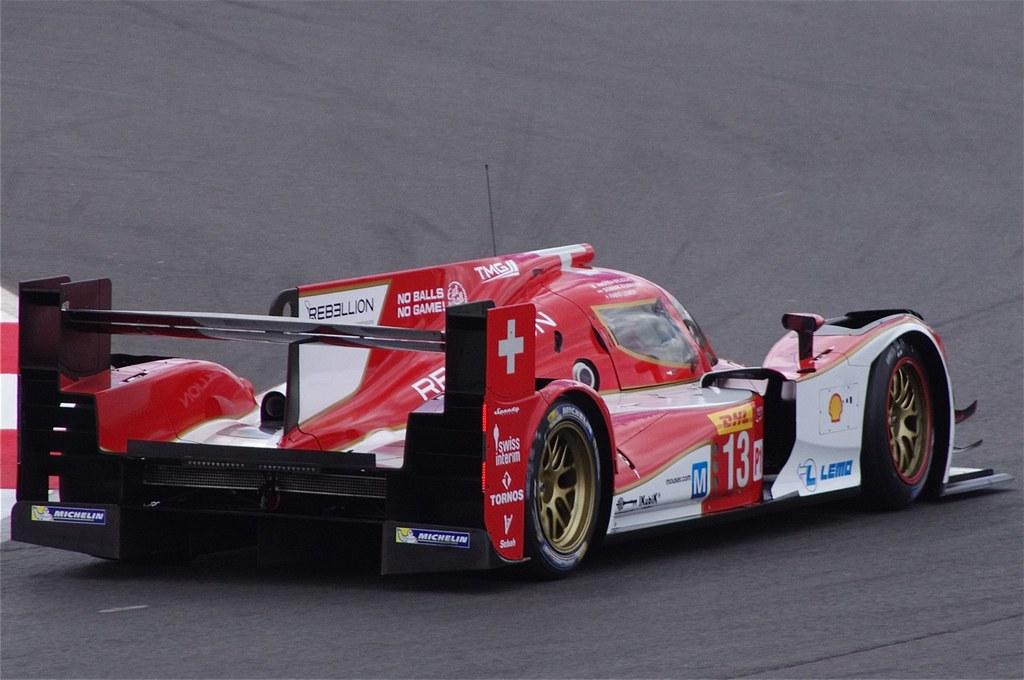What is the main subject of the image? There is a vehicle in the image. Where is the vehicle located? The vehicle is on the road. What type of sand can be seen in the image? There is no sand present in the image; it features a vehicle on the road. What kind of loss is depicted in the image? There is no loss depicted in the image; it features a vehicle on the road. 